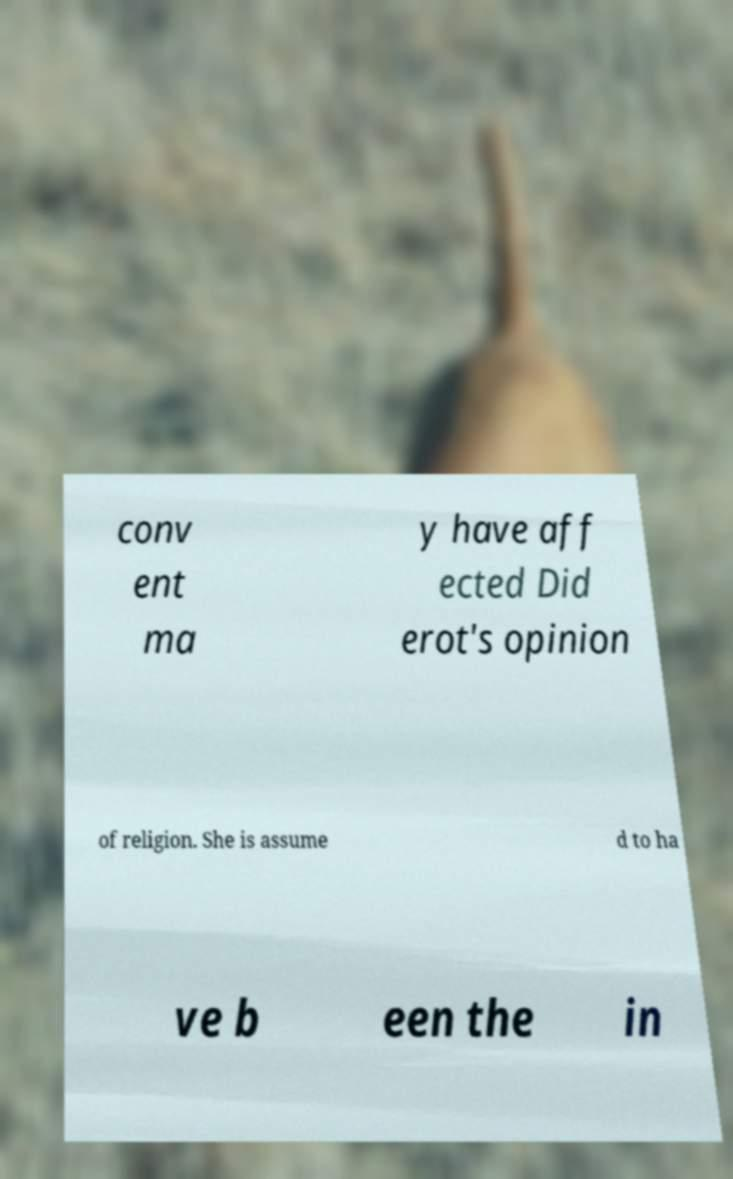There's text embedded in this image that I need extracted. Can you transcribe it verbatim? conv ent ma y have aff ected Did erot's opinion of religion. She is assume d to ha ve b een the in 